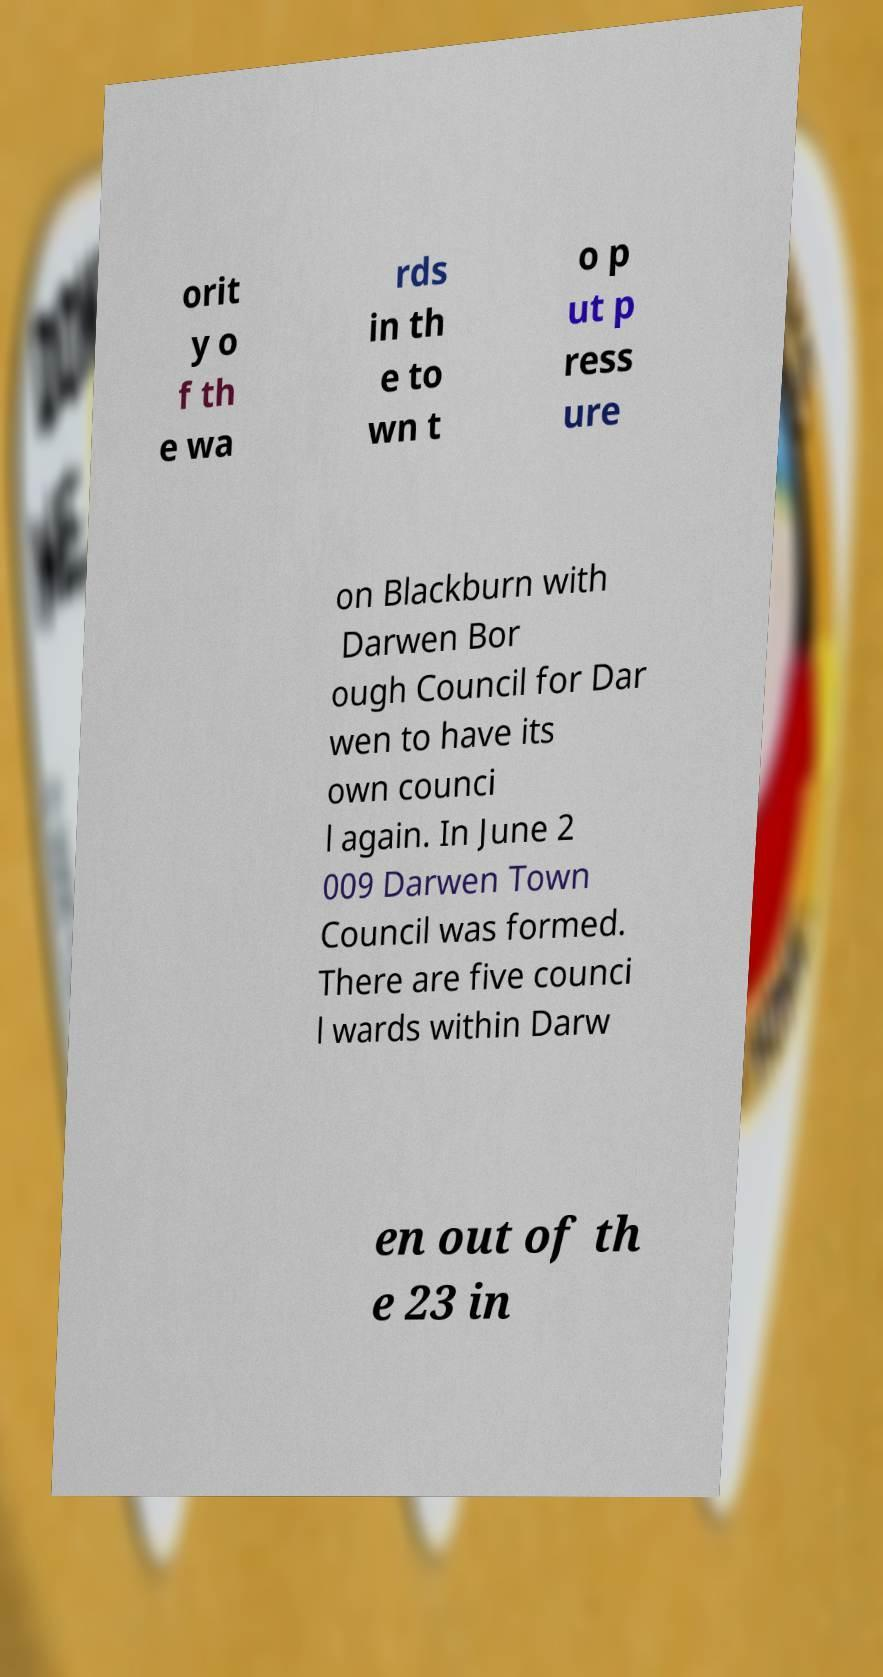There's text embedded in this image that I need extracted. Can you transcribe it verbatim? orit y o f th e wa rds in th e to wn t o p ut p ress ure on Blackburn with Darwen Bor ough Council for Dar wen to have its own counci l again. In June 2 009 Darwen Town Council was formed. There are five counci l wards within Darw en out of th e 23 in 